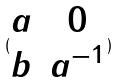Convert formula to latex. <formula><loc_0><loc_0><loc_500><loc_500>( \begin{matrix} a & 0 \\ b & a ^ { - 1 } \end{matrix} )</formula> 